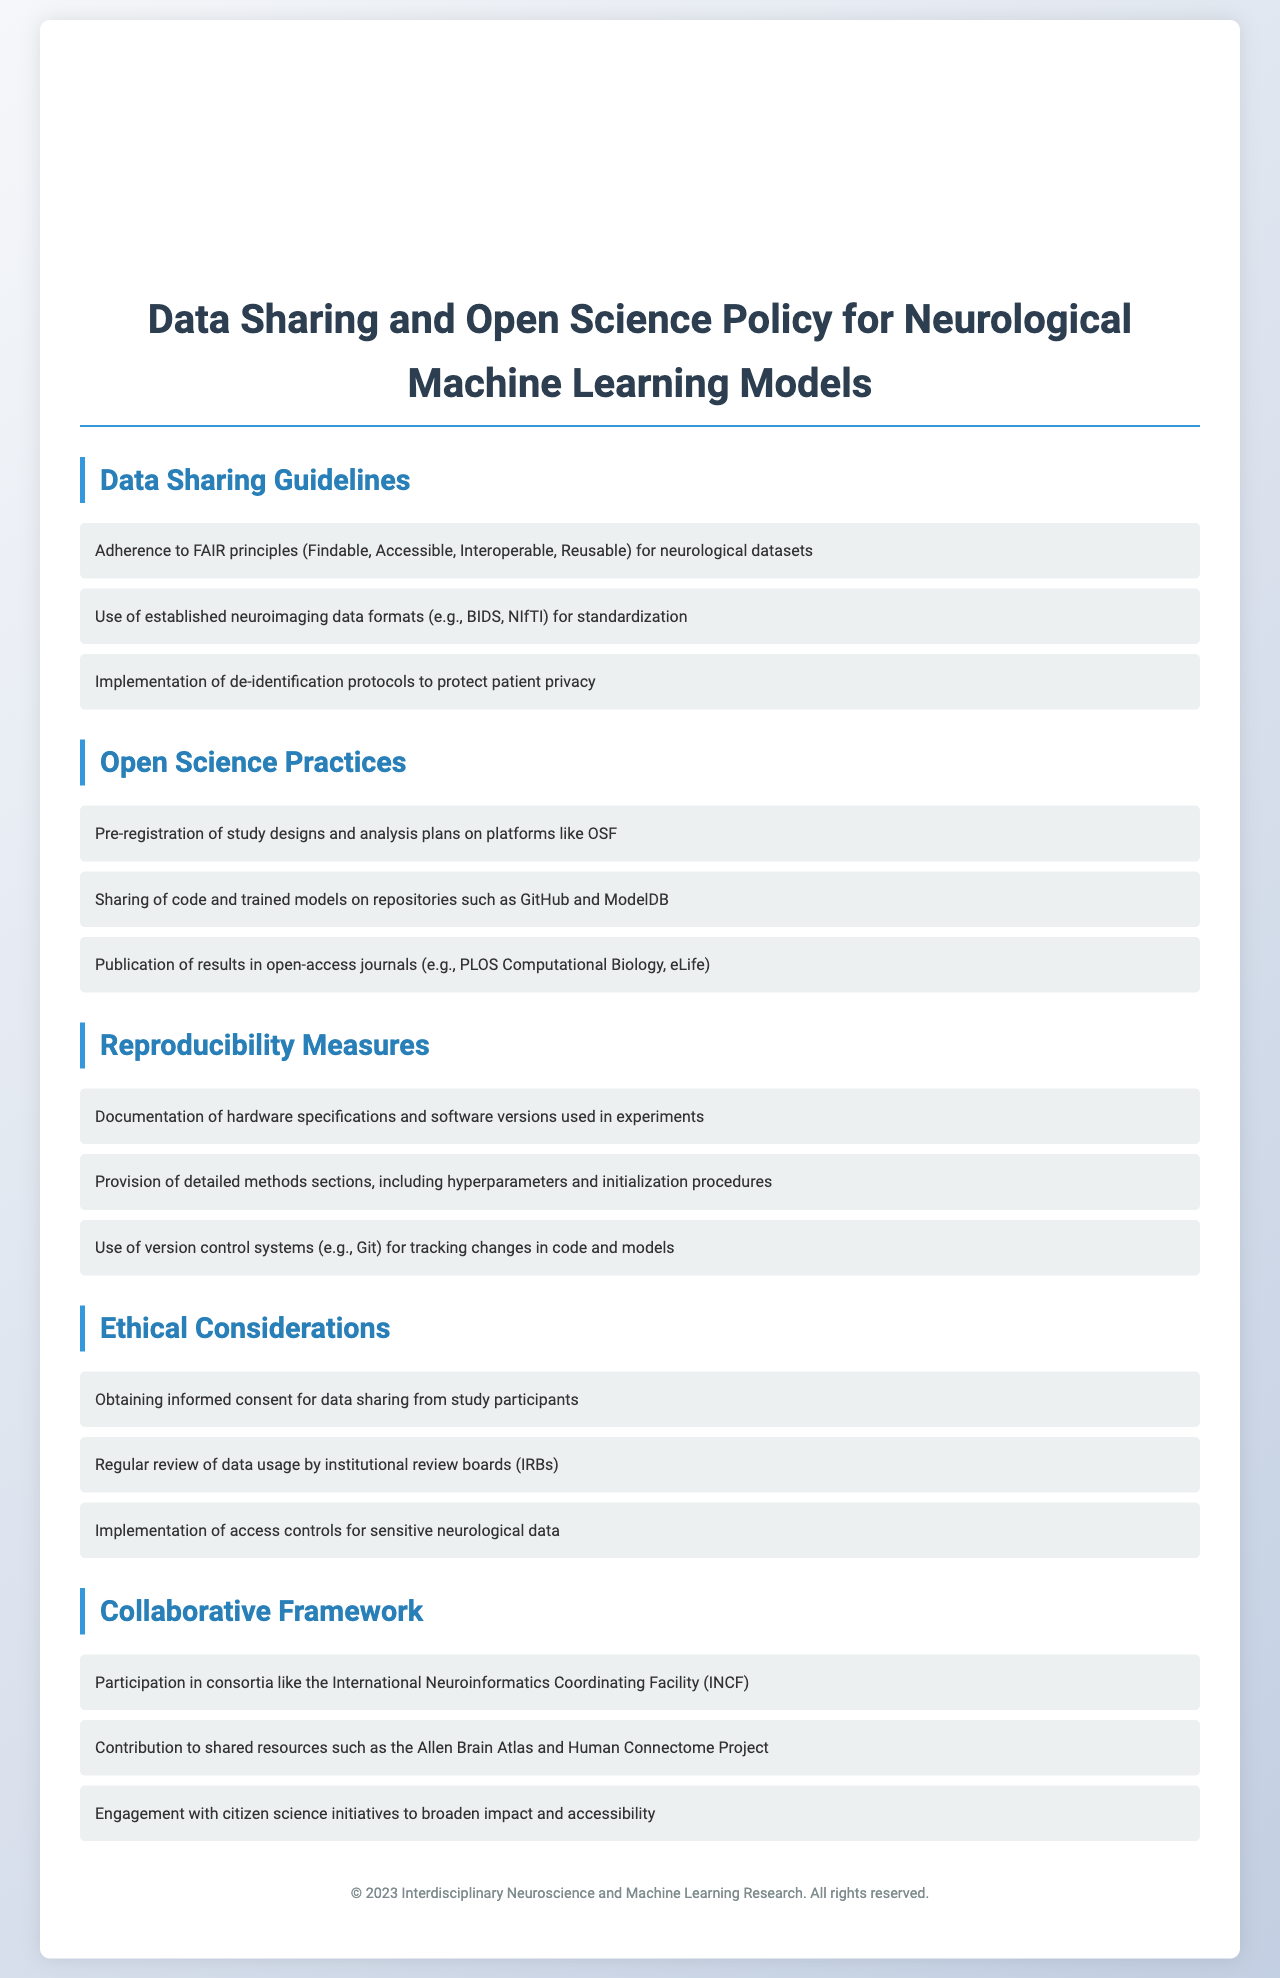What are the principles referred to in the Data Sharing Guidelines? The Data Sharing Guidelines mention the FAIR principles which stand for Findable, Accessible, Interoperable, Reusable.
Answer: FAIR principles What formats are recommended for neuroimaging data? The document suggests using established neuroimaging data formats, specifically BIDS and NIfTI.
Answer: BIDS, NIfTI What actions should researchers take regarding informed consent? Researchers must obtain informed consent for data sharing from study participants, as highlighted in the Ethics section.
Answer: Informed consent Which platforms are suggested for pre-registering study designs? The policy document recommends using platforms like OSF for pre-registering study designs and analysis plans.
Answer: OSF How often should data usage be reviewed? The document states that data usage should be regularly reviewed by institutional review boards (IRBs).
Answer: Regularly What are the key measures for reproducibility mentioned? Key measures include documenting hardware specifications, providing detailed methods sections, and using version control systems.
Answer: Documentation, methods, version control What collaborative entities are mentioned for participation? Researchers are encouraged to participate in consortia like the International Neuroinformatics Coordinating Facility (INCF).
Answer: INCF How can researchers share their code and models? The document states that researchers can share code and trained models on repositories such as GitHub and ModelDB.
Answer: GitHub, ModelDB 